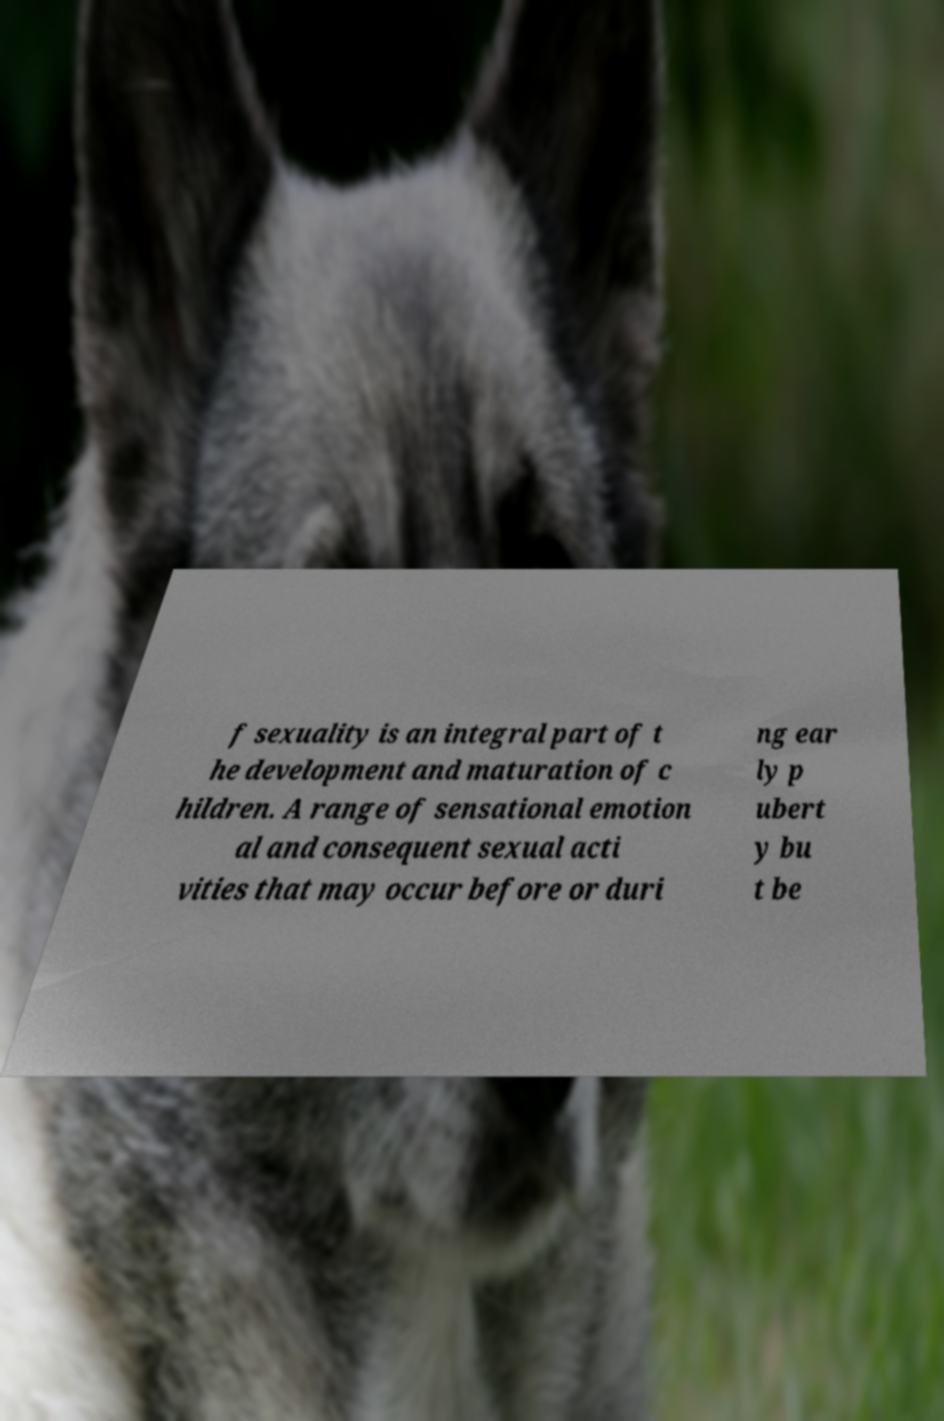For documentation purposes, I need the text within this image transcribed. Could you provide that? f sexuality is an integral part of t he development and maturation of c hildren. A range of sensational emotion al and consequent sexual acti vities that may occur before or duri ng ear ly p ubert y bu t be 